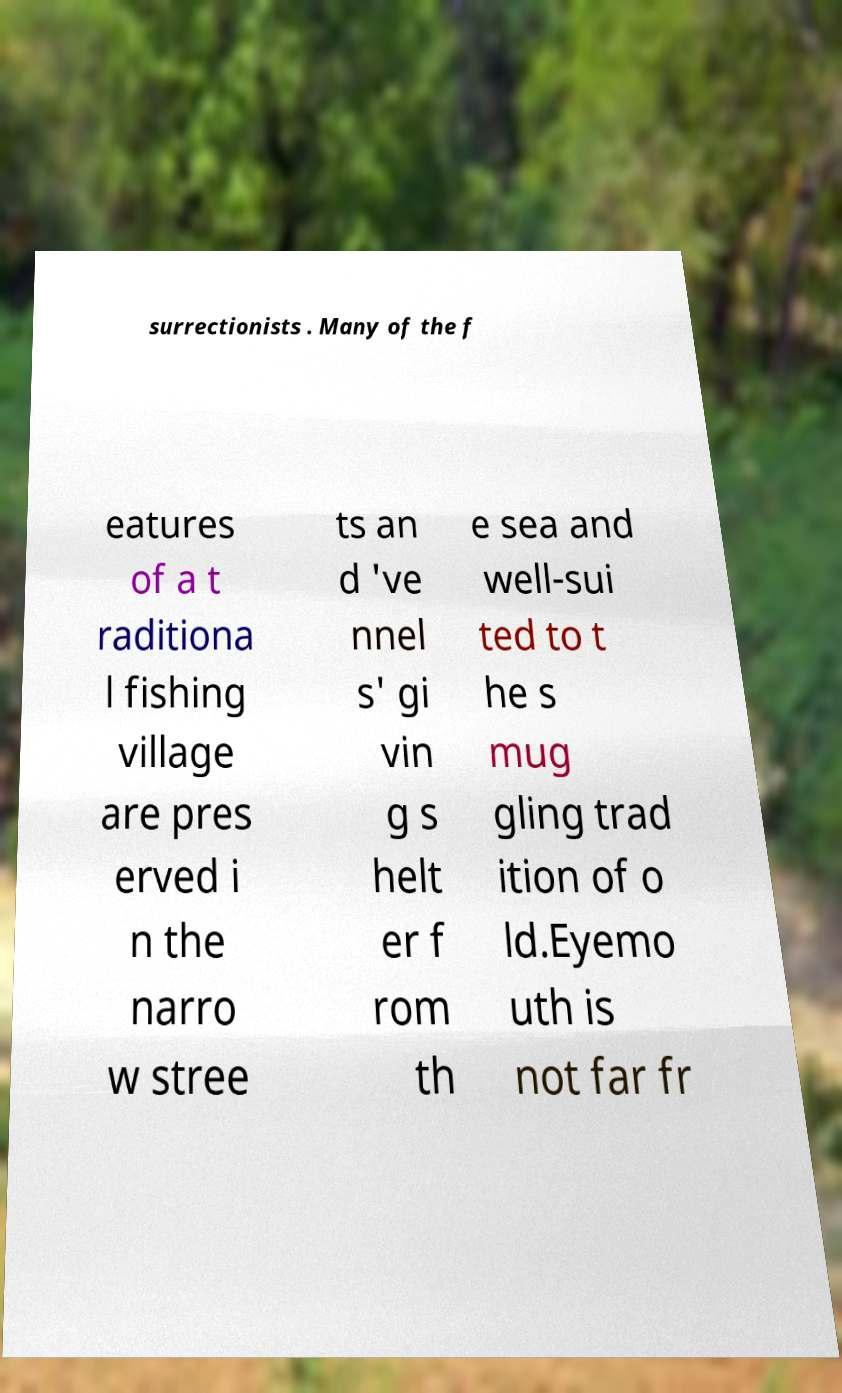Can you accurately transcribe the text from the provided image for me? surrectionists . Many of the f eatures of a t raditiona l fishing village are pres erved i n the narro w stree ts an d 've nnel s' gi vin g s helt er f rom th e sea and well-sui ted to t he s mug gling trad ition of o ld.Eyemo uth is not far fr 